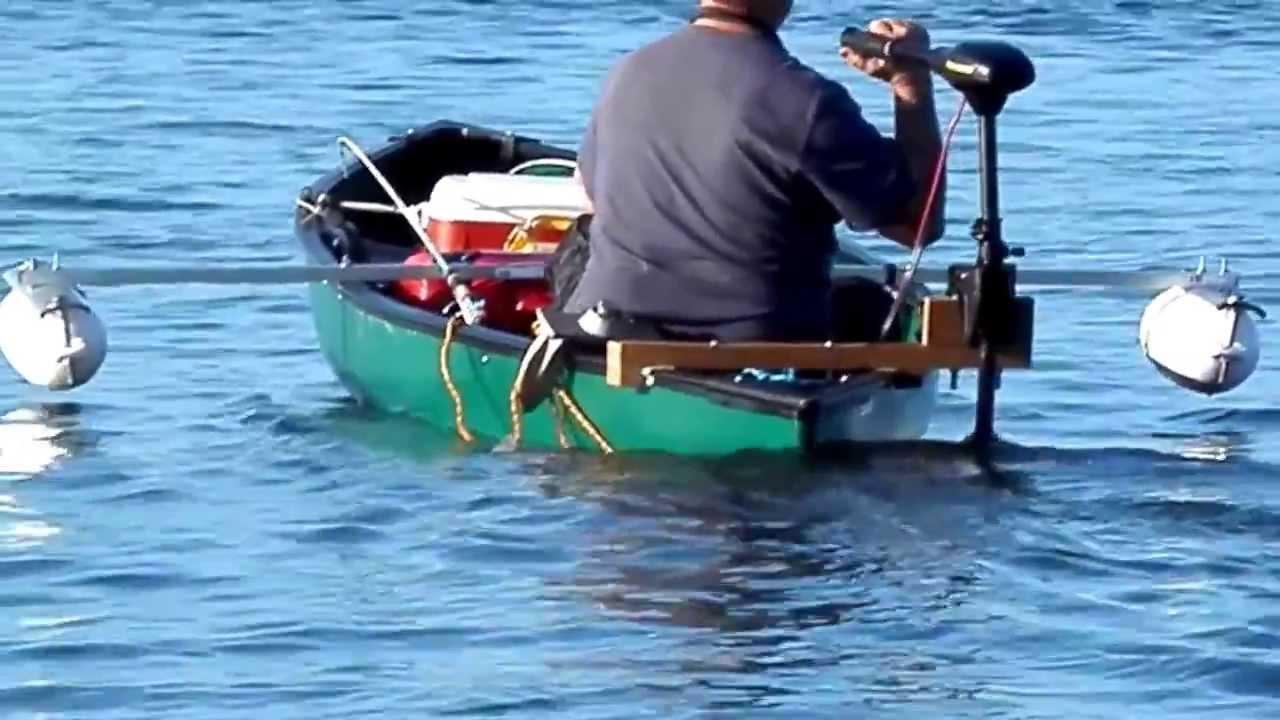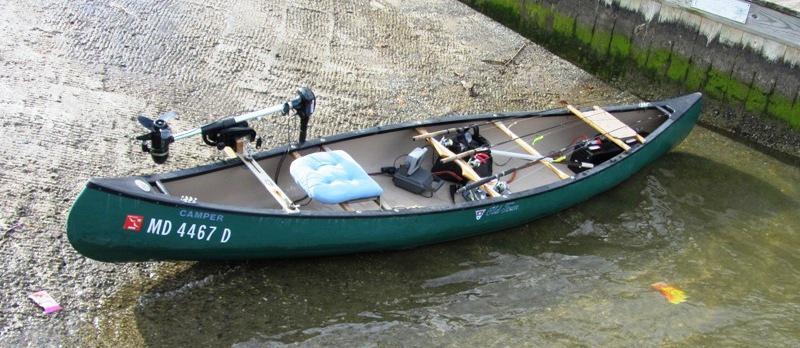The first image is the image on the left, the second image is the image on the right. For the images displayed, is the sentence "At least one person is in a green canoe on the water." factually correct? Answer yes or no. Yes. 